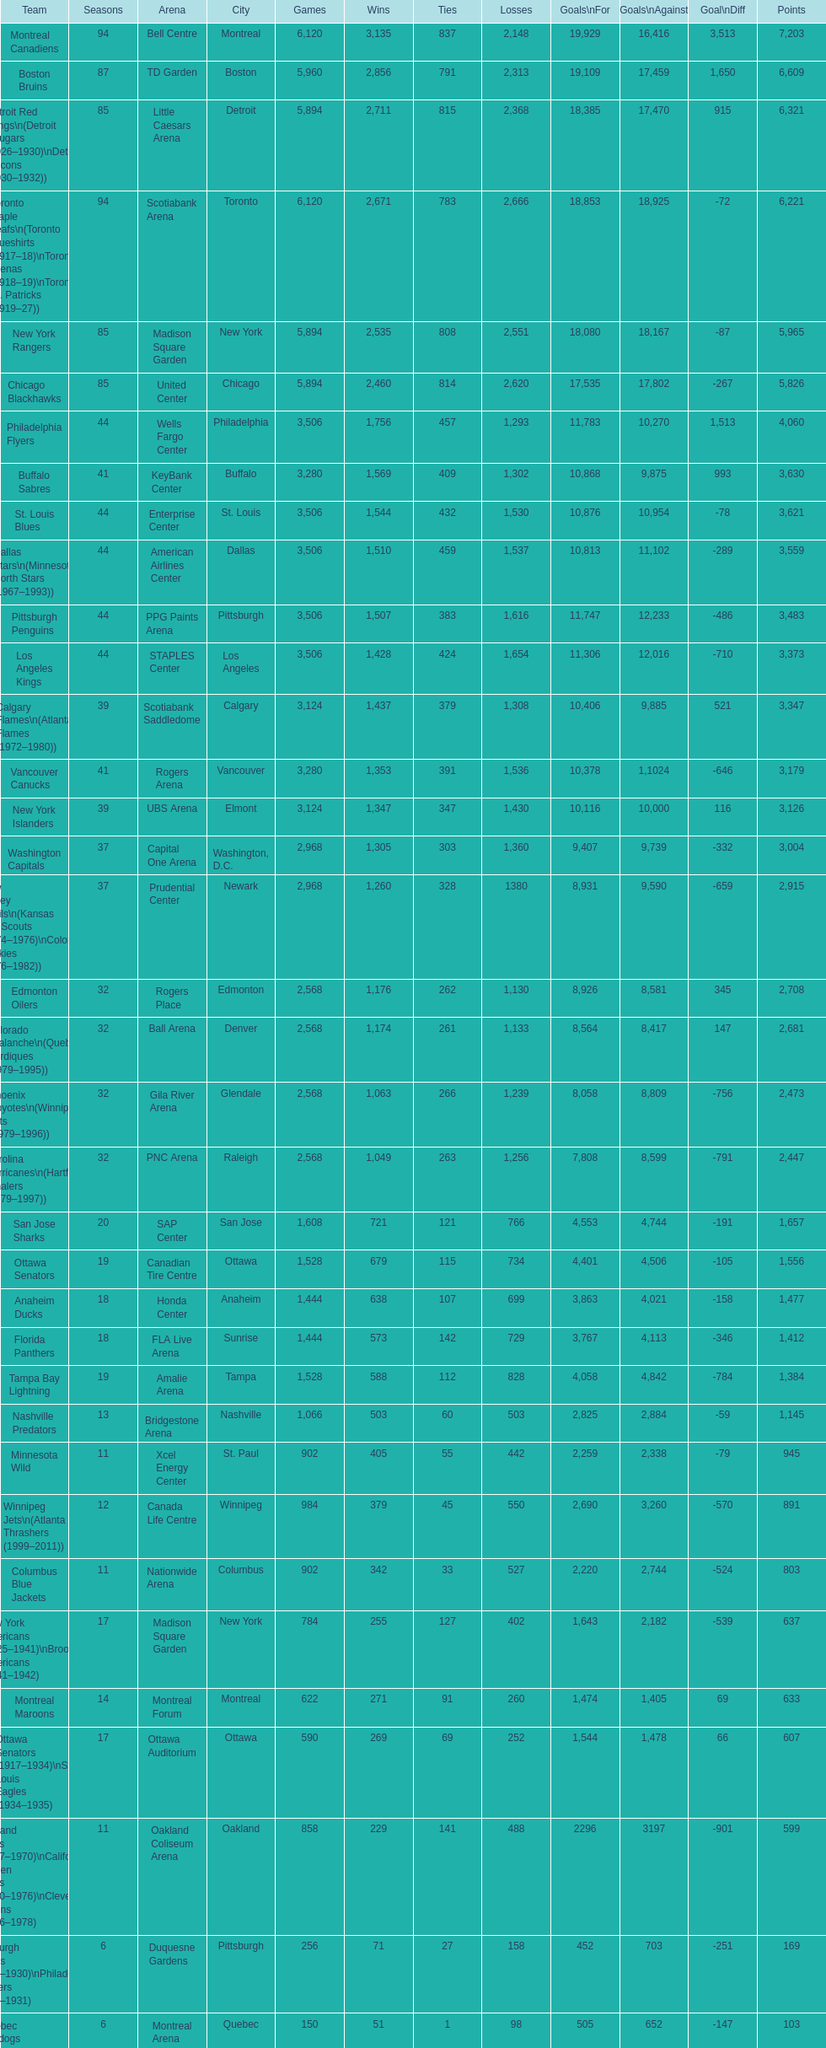What is the number of games that the vancouver canucks have won up to this point? 1,353. 